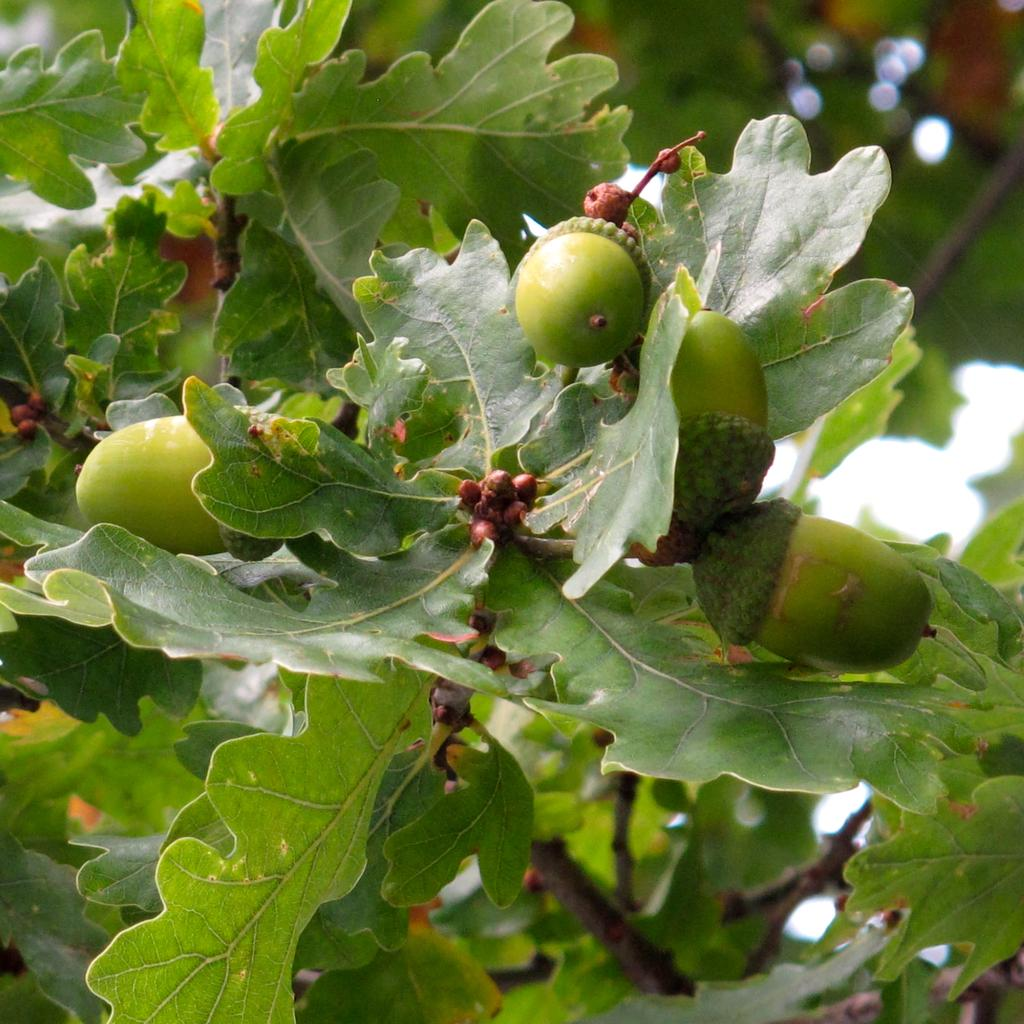What type of tree is in the image? There is a fig tree in the image. Are there any fruits visible on the tree? Yes, the fig tree has figs on it. What type of furniture is being used by the government in the image? There is no furniture or government present in the image; it only features a fig tree with figs on it. 